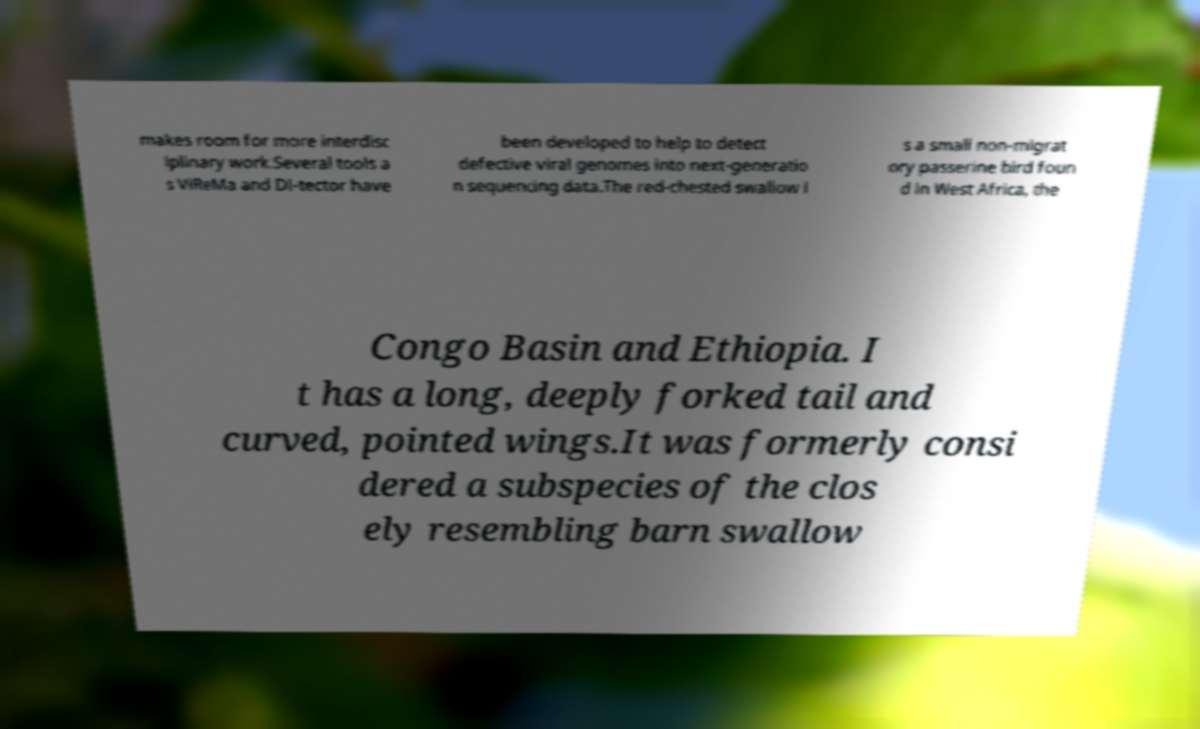Could you assist in decoding the text presented in this image and type it out clearly? makes room for more interdisc iplinary work.Several tools a s ViReMa and DI-tector have been developed to help to detect defective viral genomes into next-generatio n sequencing data.The red-chested swallow i s a small non-migrat ory passerine bird foun d in West Africa, the Congo Basin and Ethiopia. I t has a long, deeply forked tail and curved, pointed wings.It was formerly consi dered a subspecies of the clos ely resembling barn swallow 